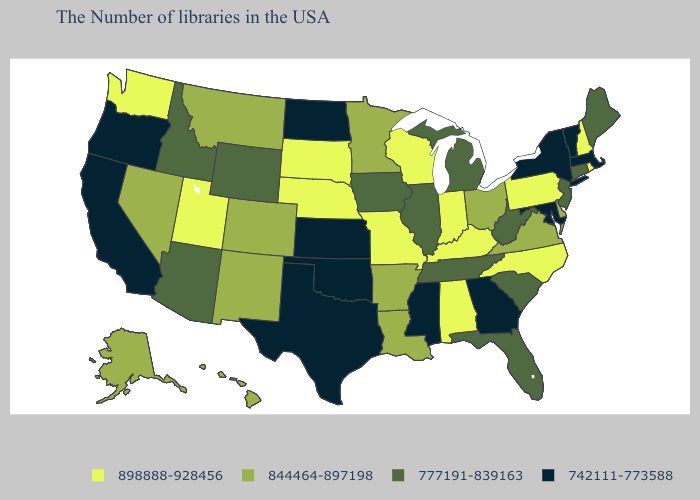How many symbols are there in the legend?
Quick response, please. 4. Name the states that have a value in the range 898888-928456?
Keep it brief. Rhode Island, New Hampshire, Pennsylvania, North Carolina, Kentucky, Indiana, Alabama, Wisconsin, Missouri, Nebraska, South Dakota, Utah, Washington. Does Pennsylvania have the highest value in the USA?
Short answer required. Yes. What is the value of New Jersey?
Give a very brief answer. 777191-839163. Does Rhode Island have the lowest value in the Northeast?
Write a very short answer. No. What is the value of Indiana?
Short answer required. 898888-928456. Name the states that have a value in the range 777191-839163?
Answer briefly. Maine, Connecticut, New Jersey, South Carolina, West Virginia, Florida, Michigan, Tennessee, Illinois, Iowa, Wyoming, Arizona, Idaho. Does Wyoming have the lowest value in the USA?
Answer briefly. No. Name the states that have a value in the range 844464-897198?
Answer briefly. Delaware, Virginia, Ohio, Louisiana, Arkansas, Minnesota, Colorado, New Mexico, Montana, Nevada, Alaska, Hawaii. What is the value of Alabama?
Keep it brief. 898888-928456. Which states have the lowest value in the USA?
Keep it brief. Massachusetts, Vermont, New York, Maryland, Georgia, Mississippi, Kansas, Oklahoma, Texas, North Dakota, California, Oregon. Does North Dakota have the lowest value in the USA?
Keep it brief. Yes. Name the states that have a value in the range 898888-928456?
Quick response, please. Rhode Island, New Hampshire, Pennsylvania, North Carolina, Kentucky, Indiana, Alabama, Wisconsin, Missouri, Nebraska, South Dakota, Utah, Washington. How many symbols are there in the legend?
Concise answer only. 4. Name the states that have a value in the range 742111-773588?
Quick response, please. Massachusetts, Vermont, New York, Maryland, Georgia, Mississippi, Kansas, Oklahoma, Texas, North Dakota, California, Oregon. 